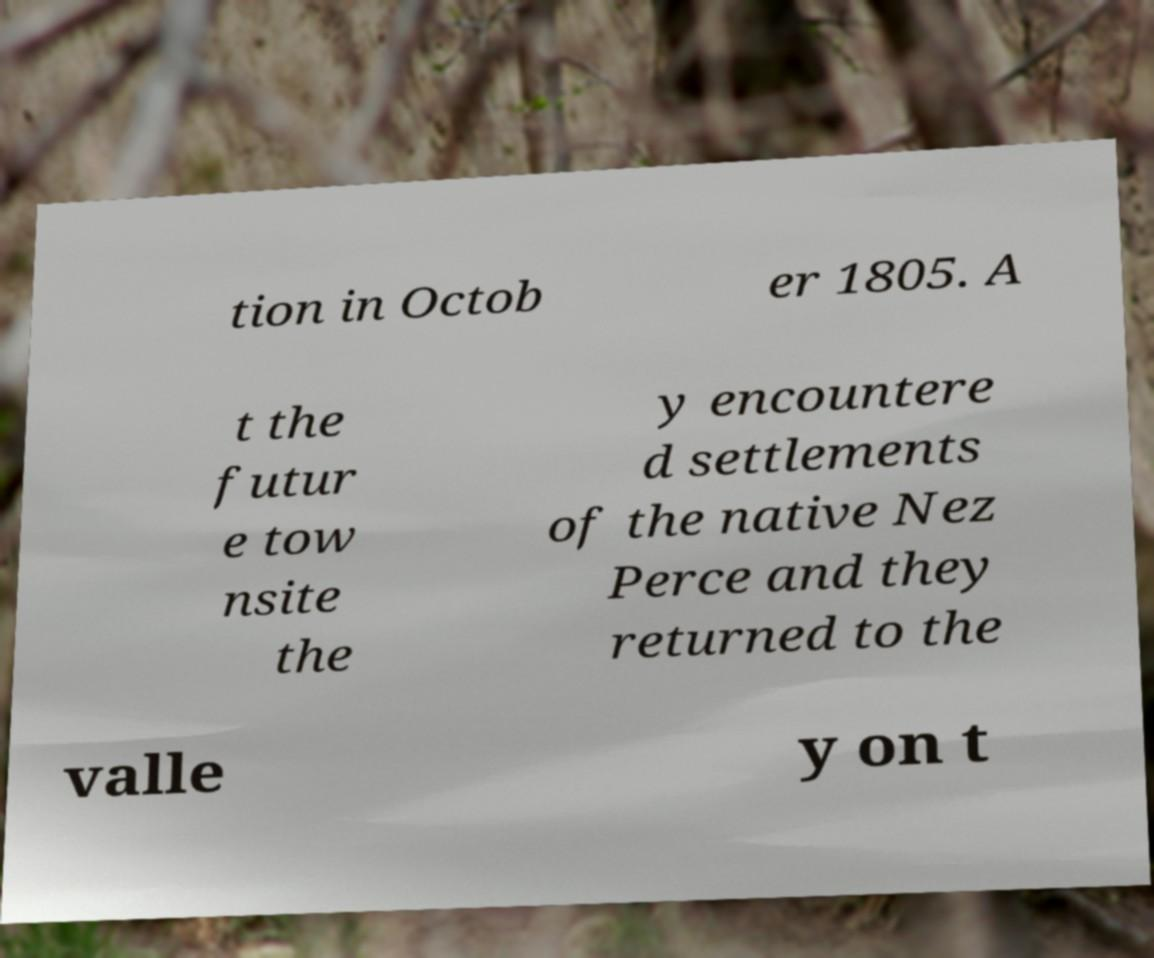Could you assist in decoding the text presented in this image and type it out clearly? tion in Octob er 1805. A t the futur e tow nsite the y encountere d settlements of the native Nez Perce and they returned to the valle y on t 